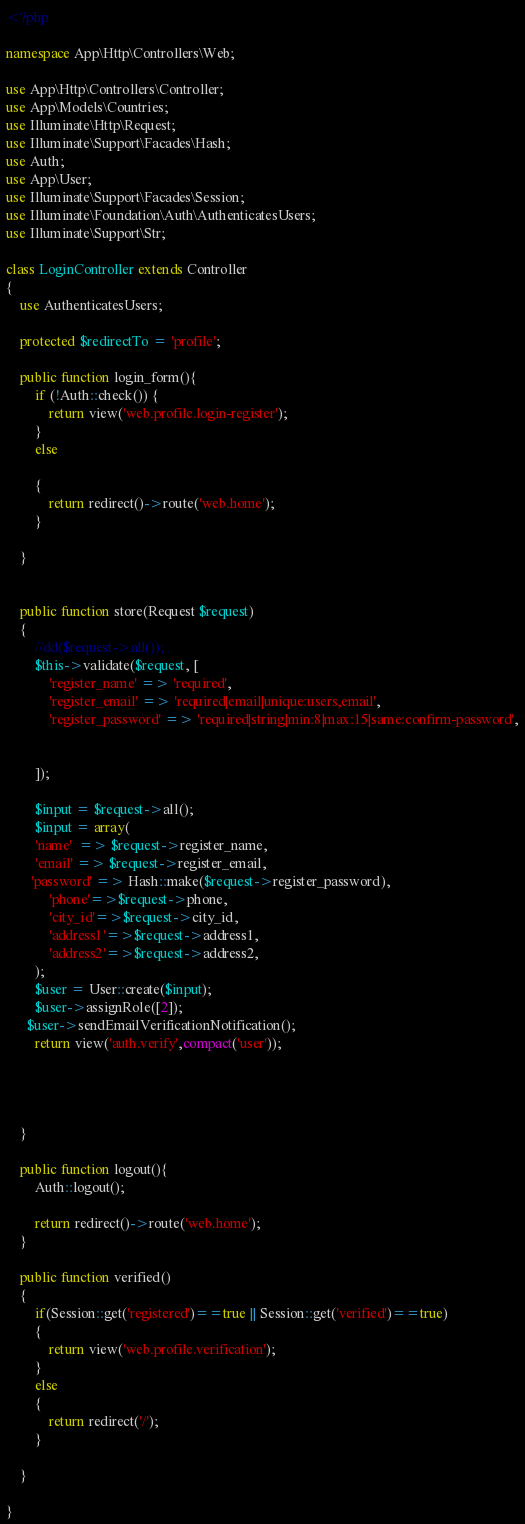Convert code to text. <code><loc_0><loc_0><loc_500><loc_500><_PHP_><?php

namespace App\Http\Controllers\Web;

use App\Http\Controllers\Controller;
use App\Models\Countries;
use Illuminate\Http\Request;
use Illuminate\Support\Facades\Hash;
use Auth;
use App\User;
use Illuminate\Support\Facades\Session;
use Illuminate\Foundation\Auth\AuthenticatesUsers;
use Illuminate\Support\Str;

class LoginController extends Controller
{
    use AuthenticatesUsers;

    protected $redirectTo = 'profile';

    public function login_form(){
        if (!Auth::check()) {
            return view('web.profile.login-register');
        }
        else

        {
            return redirect()->route('web.home');
        }

    }


    public function store(Request $request)
    {
        //dd($request->all());
        $this->validate($request, [
            'register_name' => 'required',
            'register_email' => 'required|email|unique:users,email',
            'register_password' => 'required|string|min:8|max:15|same:confirm-password',


        ]);

        $input = $request->all();
        $input = array(
        'name'  => $request->register_name,
        'email' => $request->register_email,
       'password' => Hash::make($request->register_password),
            'phone'=>$request->phone,
            'city_id'=>$request->city_id,
            'address1'=>$request->address1,
            'address2'=>$request->address2,
        );
        $user = User::create($input);
        $user->assignRole([2]);
      $user->sendEmailVerificationNotification();
        return view('auth.verify',compact('user'));




    }

    public function logout(){
        Auth::logout();

        return redirect()->route('web.home');
    }

    public function verified()
    {
        if(Session::get('registered')==true || Session::get('verified')==true)
        {
            return view('web.profile.verification');
        }
        else
        {
            return redirect('/');
        }

    }

}
</code> 